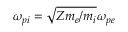Convert formula to latex. <formula><loc_0><loc_0><loc_500><loc_500>\omega _ { p i } = \sqrt { Z m _ { e } / m _ { i } } \omega _ { p e }</formula> 